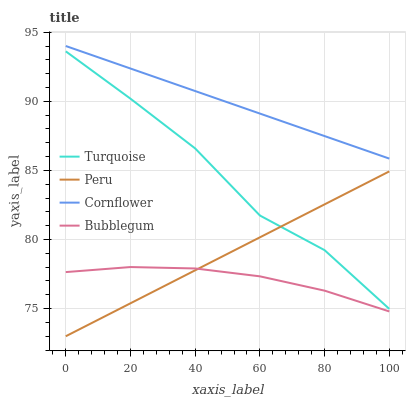Does Bubblegum have the minimum area under the curve?
Answer yes or no. Yes. Does Cornflower have the maximum area under the curve?
Answer yes or no. Yes. Does Turquoise have the minimum area under the curve?
Answer yes or no. No. Does Turquoise have the maximum area under the curve?
Answer yes or no. No. Is Cornflower the smoothest?
Answer yes or no. Yes. Is Turquoise the roughest?
Answer yes or no. Yes. Is Bubblegum the smoothest?
Answer yes or no. No. Is Bubblegum the roughest?
Answer yes or no. No. Does Peru have the lowest value?
Answer yes or no. Yes. Does Turquoise have the lowest value?
Answer yes or no. No. Does Cornflower have the highest value?
Answer yes or no. Yes. Does Turquoise have the highest value?
Answer yes or no. No. Is Bubblegum less than Turquoise?
Answer yes or no. Yes. Is Cornflower greater than Peru?
Answer yes or no. Yes. Does Peru intersect Bubblegum?
Answer yes or no. Yes. Is Peru less than Bubblegum?
Answer yes or no. No. Is Peru greater than Bubblegum?
Answer yes or no. No. Does Bubblegum intersect Turquoise?
Answer yes or no. No. 